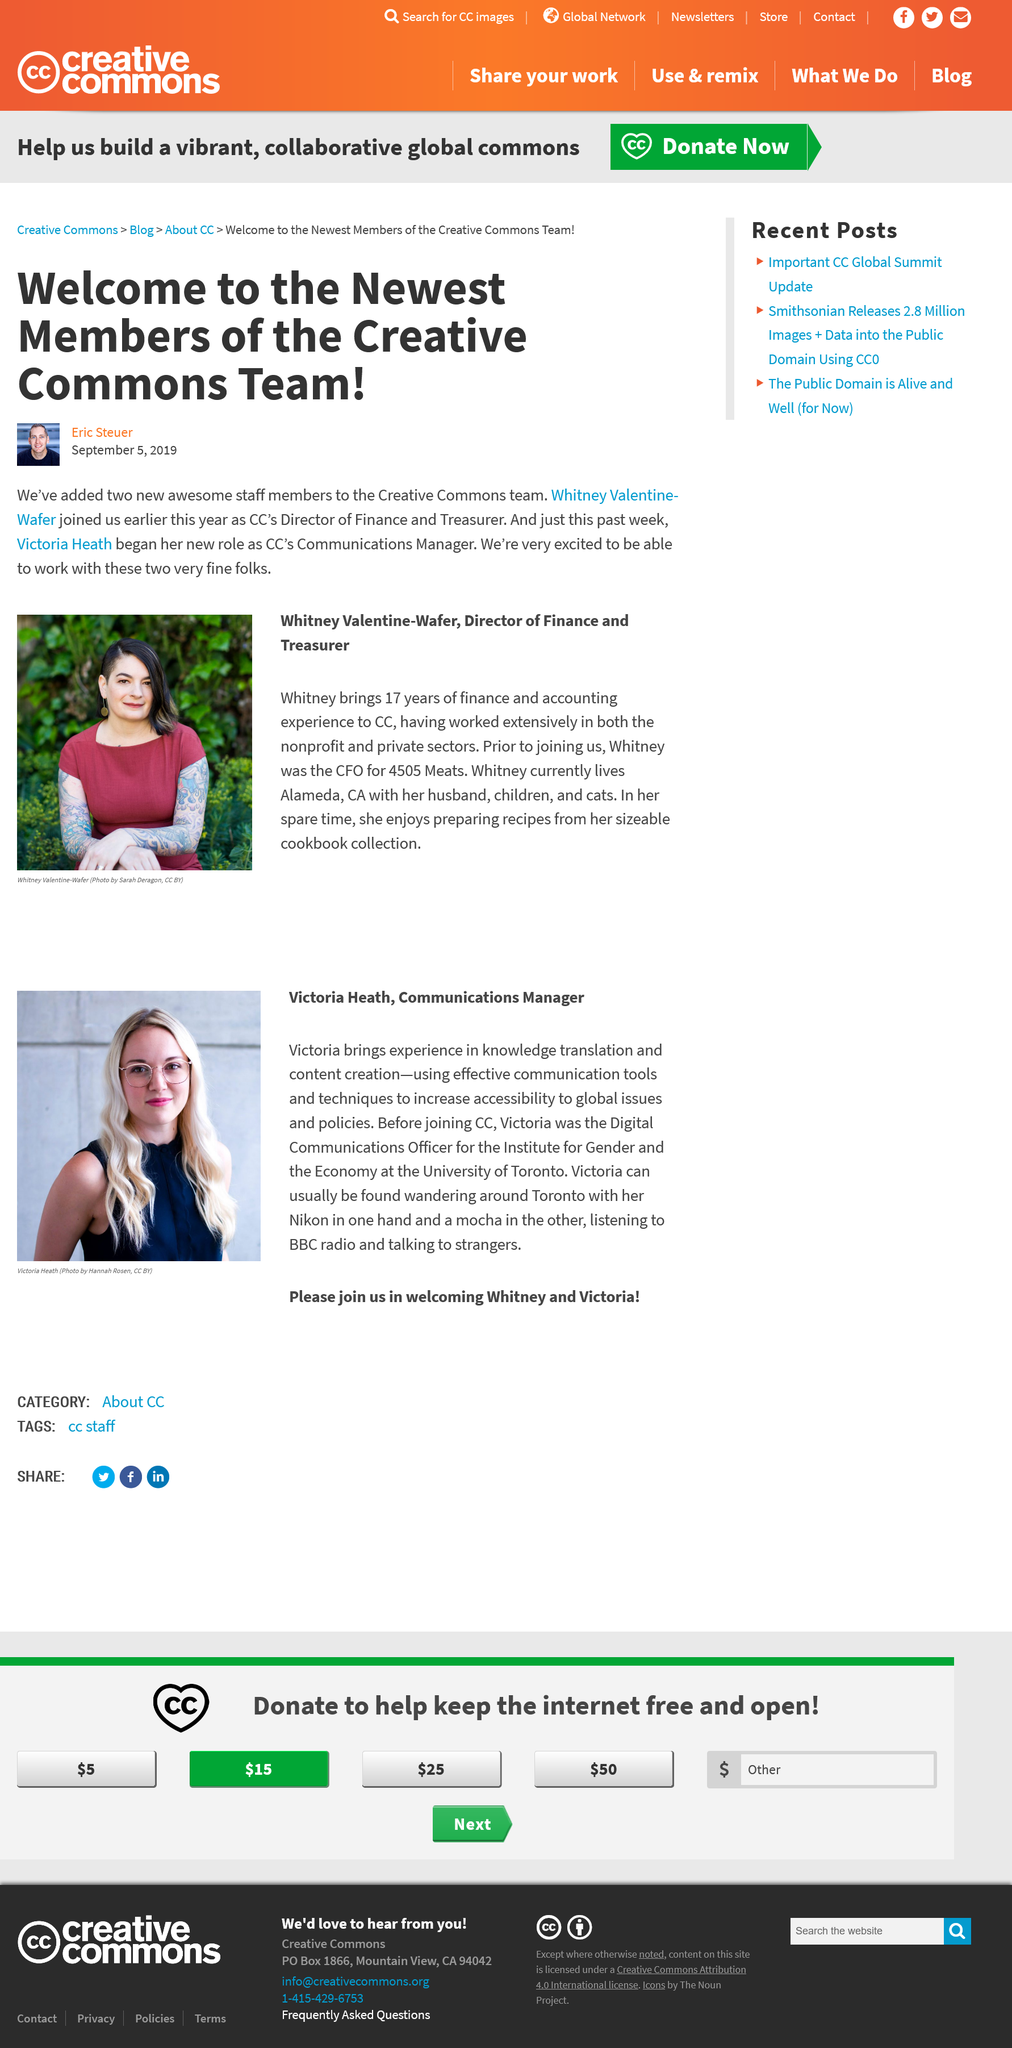List a handful of essential elements in this visual. Whitney has 17 years of experience in finance and accounting, and she brings this expertise to CC. The article written by Eric Steuer is welcoming to the new staff members of the Creative Commons team, as it is written in an enthusiastic and positive style. Yes, the article is welcoming to the new staff members of the Creative Commons team. The person shown in the photo on the left is Victoria Heath, the Communications Manager. Whitney Valentine-Wafer was photographed by Sarah Deragon. Victoria Heath is the newest Creative Commons Communications Manager, and Eric Steuer is not the name of the newest CC Communications Manager. 